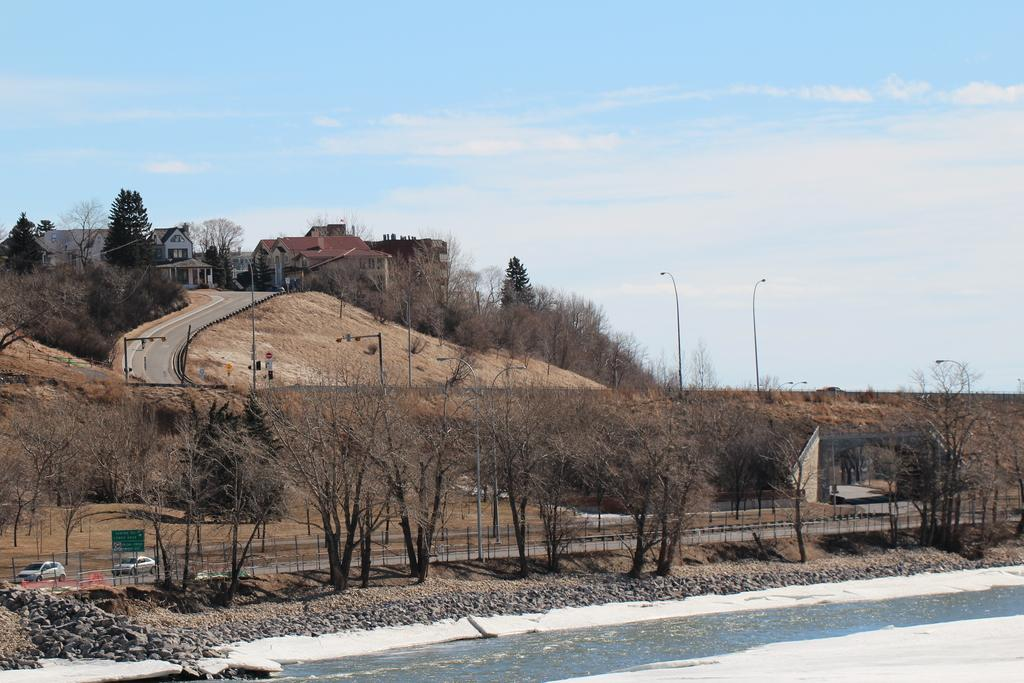What type of vegetation is visible in the image? There are trees in the image. What type of artificial light source can be seen in the image? There are street lamps in the image. What type of geographical feature is present in the image? There is a hill in the image. What type of man-made structures are present in the image? There are buildings in the image. What type of signage is present in the image? There is a banner in the image. What type of vehicles are present in the image? There are cars in the image. What part of the natural environment is visible in the image? The sky is visible in the image. Can you tell me how many bats are hanging from the street lamps in the image? There are no bats present in the image; only street lamps, trees, a hill, buildings, a banner, cars, and the sky are visible. What type of light is emitted from the banner in the image? There is no light emitted from the banner in the image; it is a stationary sign. --- Facts: 1. There is a person holding a camera in the image. 2. The person is wearing a hat. 3. The person is standing on a bridge. 4. There is a river visible in the image. 5. There are boats in the river. Absurd Topics: elephant, piano, ocean Conversation: What is the person in the image holding? The person in the image is holding a camera. What type of headwear is the person wearing? The person is wearing a hat. Where is the person standing in the image? The person is standing on a bridge. What type of water body is visible in the image? There is a river visible in the image. What type of vehicles are present in the river? There are boats in the river. Reasoning: Let's think step by step in order to produce the conversation. We start by identifying the main subject in the image, which is the person holding a camera. Then, we expand the conversation to include other items that are also visible, such as the hat, the bridge, the river, and the boats. Each question is designed to elicit a specific detail about the image that is known from the provided facts. Absurd Question/Answer: Can you tell me how many elephants are swimming in the ocean in the image? There are no elephants or ocean present in the image; only a person holding a camera, a hat, a bridge, a river, and boats are visible. What type of musical instrument is the person playing on the bridge in the image? There is no musical instrument present in the image; the person is holding a camera and wearing a hat while standing on a bridge. 